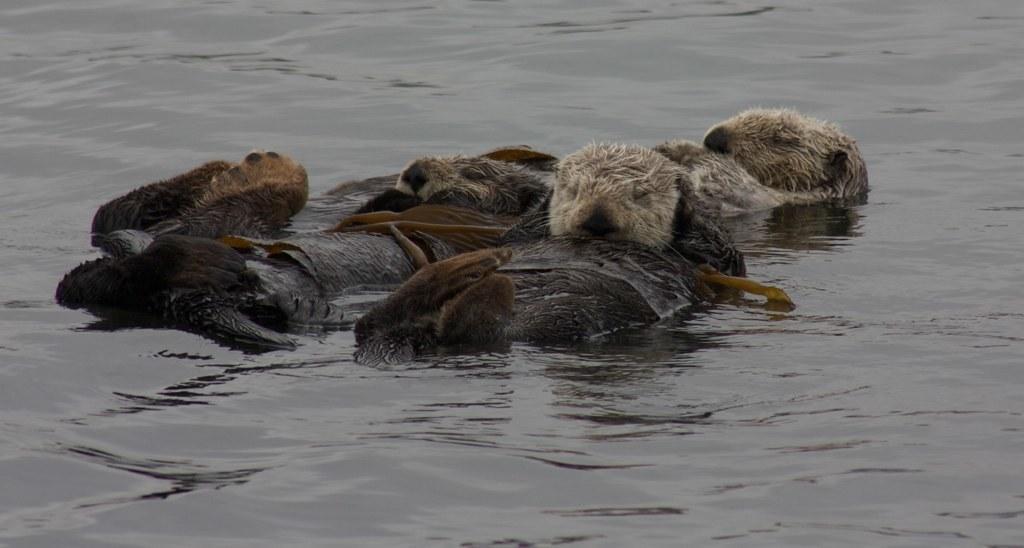In one or two sentences, can you explain what this image depicts? In the middle of the image we can see few animals in the water. 